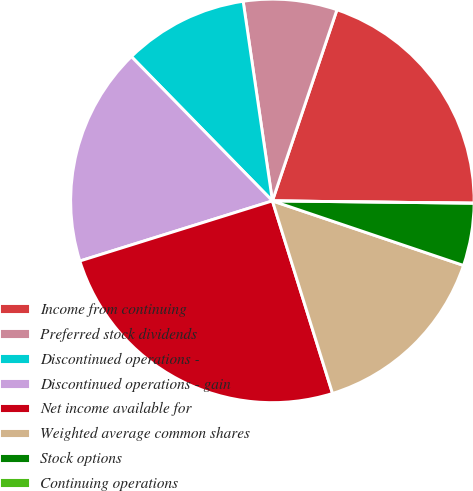<chart> <loc_0><loc_0><loc_500><loc_500><pie_chart><fcel>Income from continuing<fcel>Preferred stock dividends<fcel>Discontinued operations -<fcel>Discontinued operations - gain<fcel>Net income available for<fcel>Weighted average common shares<fcel>Stock options<fcel>Continuing operations<nl><fcel>20.0%<fcel>7.5%<fcel>10.0%<fcel>17.5%<fcel>25.0%<fcel>15.0%<fcel>5.0%<fcel>0.0%<nl></chart> 